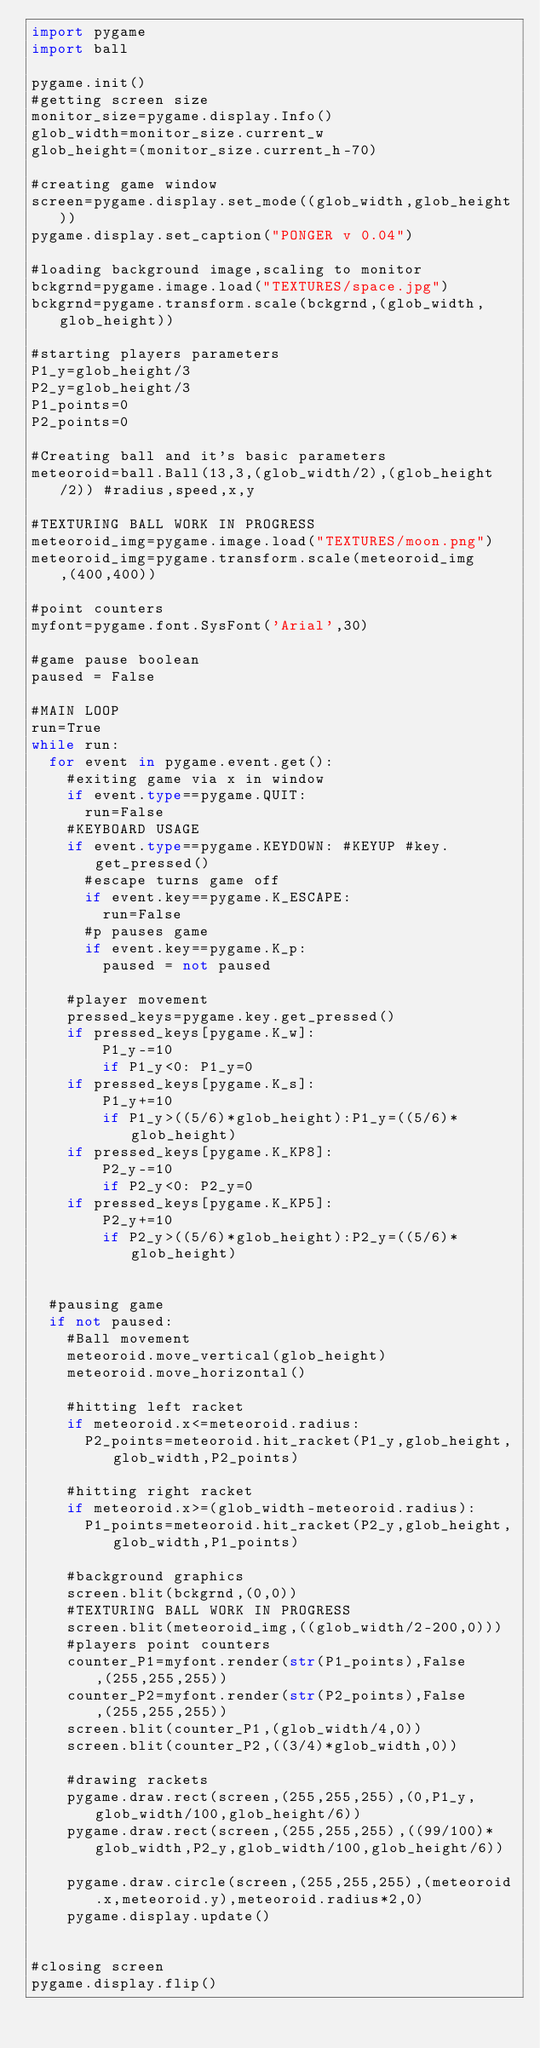Convert code to text. <code><loc_0><loc_0><loc_500><loc_500><_Python_>import pygame
import ball

pygame.init()
#getting screen size
monitor_size=pygame.display.Info()
glob_width=monitor_size.current_w
glob_height=(monitor_size.current_h-70)

#creating game window
screen=pygame.display.set_mode((glob_width,glob_height))
pygame.display.set_caption("PONGER v 0.04")

#loading background image,scaling to monitor
bckgrnd=pygame.image.load("TEXTURES/space.jpg")
bckgrnd=pygame.transform.scale(bckgrnd,(glob_width,glob_height))

#starting players parameters
P1_y=glob_height/3
P2_y=glob_height/3
P1_points=0
P2_points=0

#Creating ball and it's basic parameters
meteoroid=ball.Ball(13,3,(glob_width/2),(glob_height/2)) #radius,speed,x,y

#TEXTURING BALL WORK IN PROGRESS
meteoroid_img=pygame.image.load("TEXTURES/moon.png")
meteoroid_img=pygame.transform.scale(meteoroid_img,(400,400))

#point counters
myfont=pygame.font.SysFont('Arial',30)

#game pause boolean
paused = False

#MAIN LOOP
run=True
while run:
	for event in pygame.event.get():
		#exiting game via x in window
		if event.type==pygame.QUIT:
			run=False
		#KEYBOARD USAGE
		if event.type==pygame.KEYDOWN: #KEYUP #key.get_pressed()
			#escape turns game off
			if event.key==pygame.K_ESCAPE:
				run=False
			#p pauses game	
			if event.key==pygame.K_p:
				paused = not paused

		#player movement
		pressed_keys=pygame.key.get_pressed()
		if pressed_keys[pygame.K_w]:
				P1_y-=10				
				if P1_y<0: P1_y=0				
		if pressed_keys[pygame.K_s]:
				P1_y+=10
				if P1_y>((5/6)*glob_height):P1_y=((5/6)*glob_height)
		if pressed_keys[pygame.K_KP8]:
				P2_y-=10
				if P2_y<0: P2_y=0
		if pressed_keys[pygame.K_KP5]:
				P2_y+=10
				if P2_y>((5/6)*glob_height):P2_y=((5/6)*glob_height)


	#pausing game
	if not paused:
		#Ball movement
		meteoroid.move_vertical(glob_height)
		meteoroid.move_horizontal()

		#hitting left racket		
		if meteoroid.x<=meteoroid.radius:	
			P2_points=meteoroid.hit_racket(P1_y,glob_height,glob_width,P2_points)				

		#hitting right racket		
		if meteoroid.x>=(glob_width-meteoroid.radius):
			P1_points=meteoroid.hit_racket(P2_y,glob_height,glob_width,P1_points)		

		#background graphics
		screen.blit(bckgrnd,(0,0))
		#TEXTURING BALL WORK IN PROGRESS
		screen.blit(meteoroid_img,((glob_width/2-200,0)))
		#players point counters
		counter_P1=myfont.render(str(P1_points),False,(255,255,255))
		counter_P2=myfont.render(str(P2_points),False,(255,255,255))
		screen.blit(counter_P1,(glob_width/4,0))
		screen.blit(counter_P2,((3/4)*glob_width,0))

		#drawing rackets
		pygame.draw.rect(screen,(255,255,255),(0,P1_y,glob_width/100,glob_height/6))
		pygame.draw.rect(screen,(255,255,255),((99/100)*glob_width,P2_y,glob_width/100,glob_height/6))		
		pygame.draw.circle(screen,(255,255,255),(meteoroid.x,meteoroid.y),meteoroid.radius*2,0)
		pygame.display.update()


#closing screen
pygame.display.flip()
</code> 